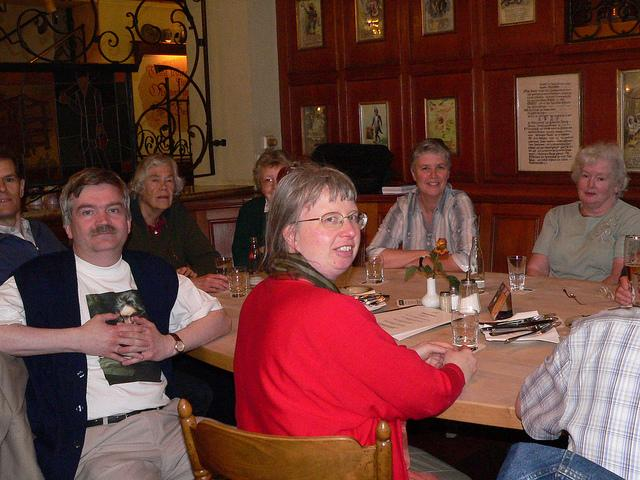What age class do most people here belong to? senior 